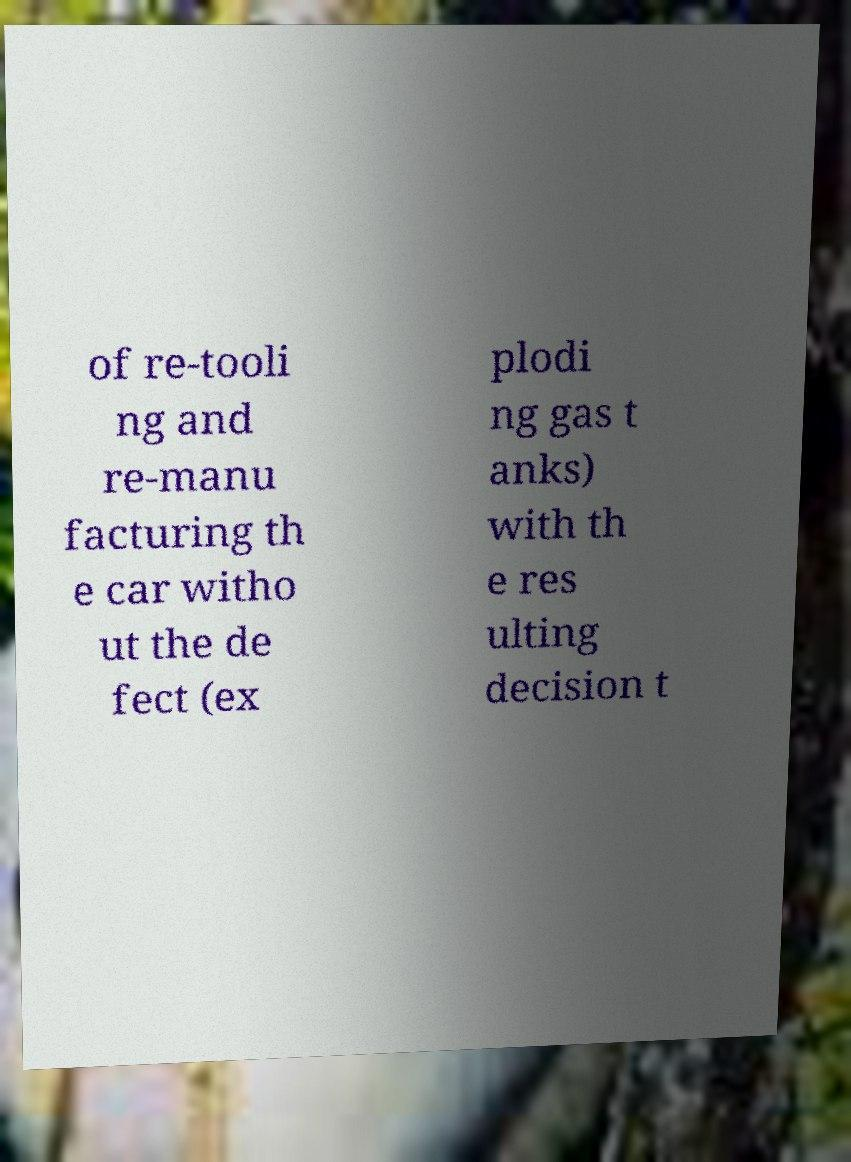What messages or text are displayed in this image? I need them in a readable, typed format. of re-tooli ng and re-manu facturing th e car witho ut the de fect (ex plodi ng gas t anks) with th e res ulting decision t 